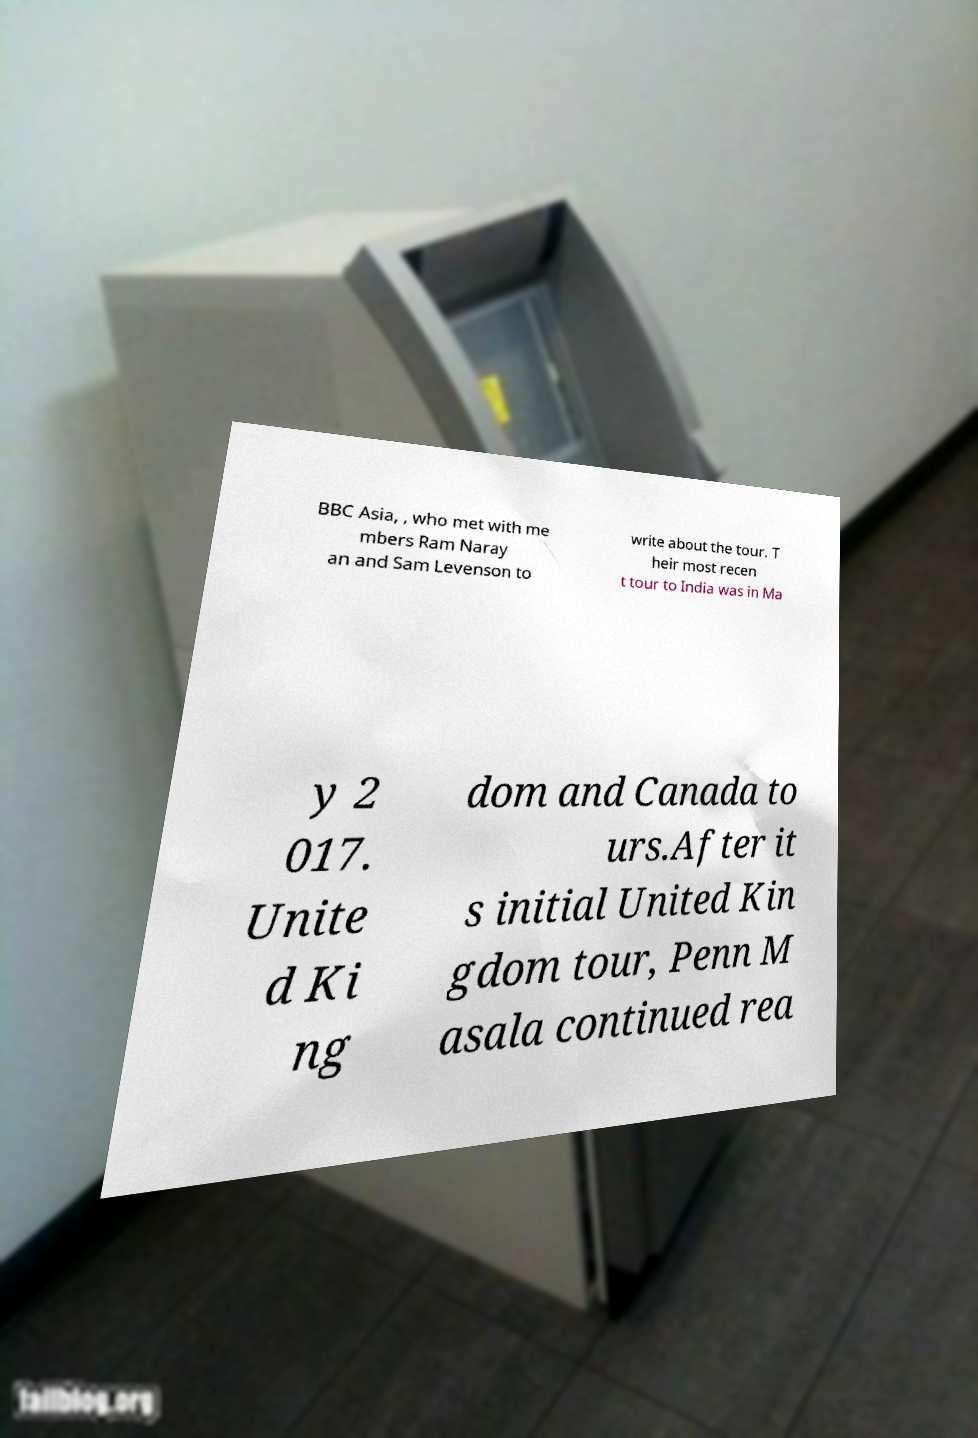I need the written content from this picture converted into text. Can you do that? BBC Asia, , who met with me mbers Ram Naray an and Sam Levenson to write about the tour. T heir most recen t tour to India was in Ma y 2 017. Unite d Ki ng dom and Canada to urs.After it s initial United Kin gdom tour, Penn M asala continued rea 